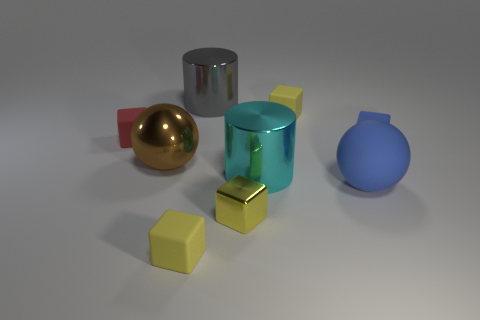Are there the same number of metallic balls that are on the right side of the big gray cylinder and big shiny objects?
Your response must be concise. No. Do the small blue matte thing and the shiny thing that is in front of the large cyan metal cylinder have the same shape?
Your answer should be compact. Yes. What size is the red object that is the same shape as the small blue rubber thing?
Your response must be concise. Small. How many other objects are there of the same material as the cyan thing?
Offer a terse response. 3. What material is the large gray thing?
Make the answer very short. Metal. There is a big rubber thing left of the tiny blue object; is it the same color as the object to the right of the matte ball?
Provide a short and direct response. Yes. Is the number of small yellow things that are to the right of the tiny metallic block greater than the number of large gray metal balls?
Make the answer very short. Yes. What number of other things are there of the same color as the large metal sphere?
Offer a terse response. 0. There is a blue matte thing on the left side of the blue cube; does it have the same size as the gray object?
Offer a very short reply. Yes. Are there any brown matte cylinders of the same size as the cyan metal cylinder?
Provide a short and direct response. No. 